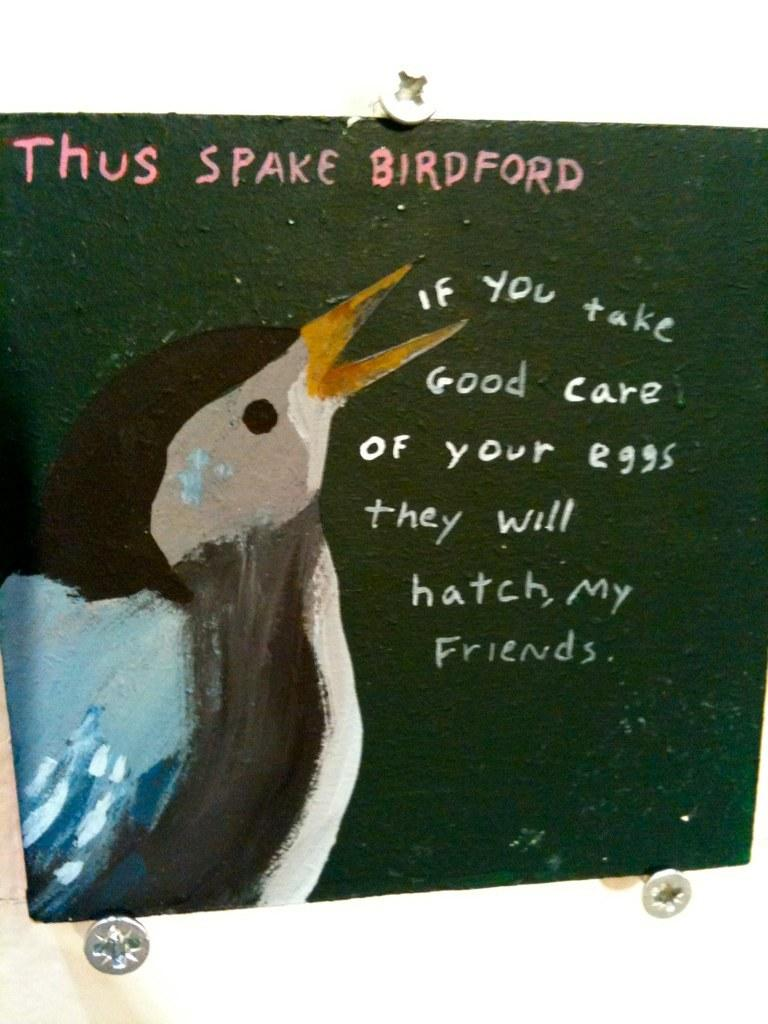What is the main subject of the image? There is a depiction of a bird in the image. Are there any words or letters in the image? Yes, there is text written in the image. What color is the background of the image? The background of the image has a green color. What type of texture can be seen on the bird's feathers in the image? There is no information about the texture of the bird's feathers in the image, as it only provides information about the bird's depiction and the presence of text. 